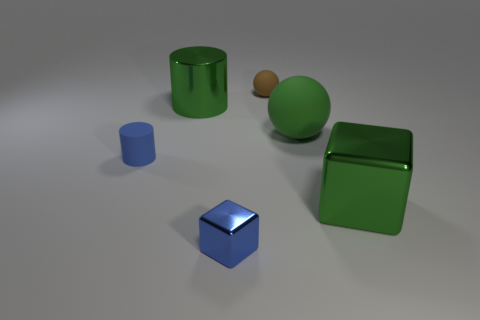Subtract all blue cylinders. How many cylinders are left? 1 Add 3 small gray cubes. How many objects exist? 9 Subtract 1 spheres. How many spheres are left? 1 Subtract all green metallic blocks. Subtract all green balls. How many objects are left? 4 Add 2 blocks. How many blocks are left? 4 Add 1 tiny rubber cylinders. How many tiny rubber cylinders exist? 2 Subtract 0 blue balls. How many objects are left? 6 Subtract all blue blocks. Subtract all cyan cylinders. How many blocks are left? 1 Subtract all brown spheres. How many yellow cylinders are left? 0 